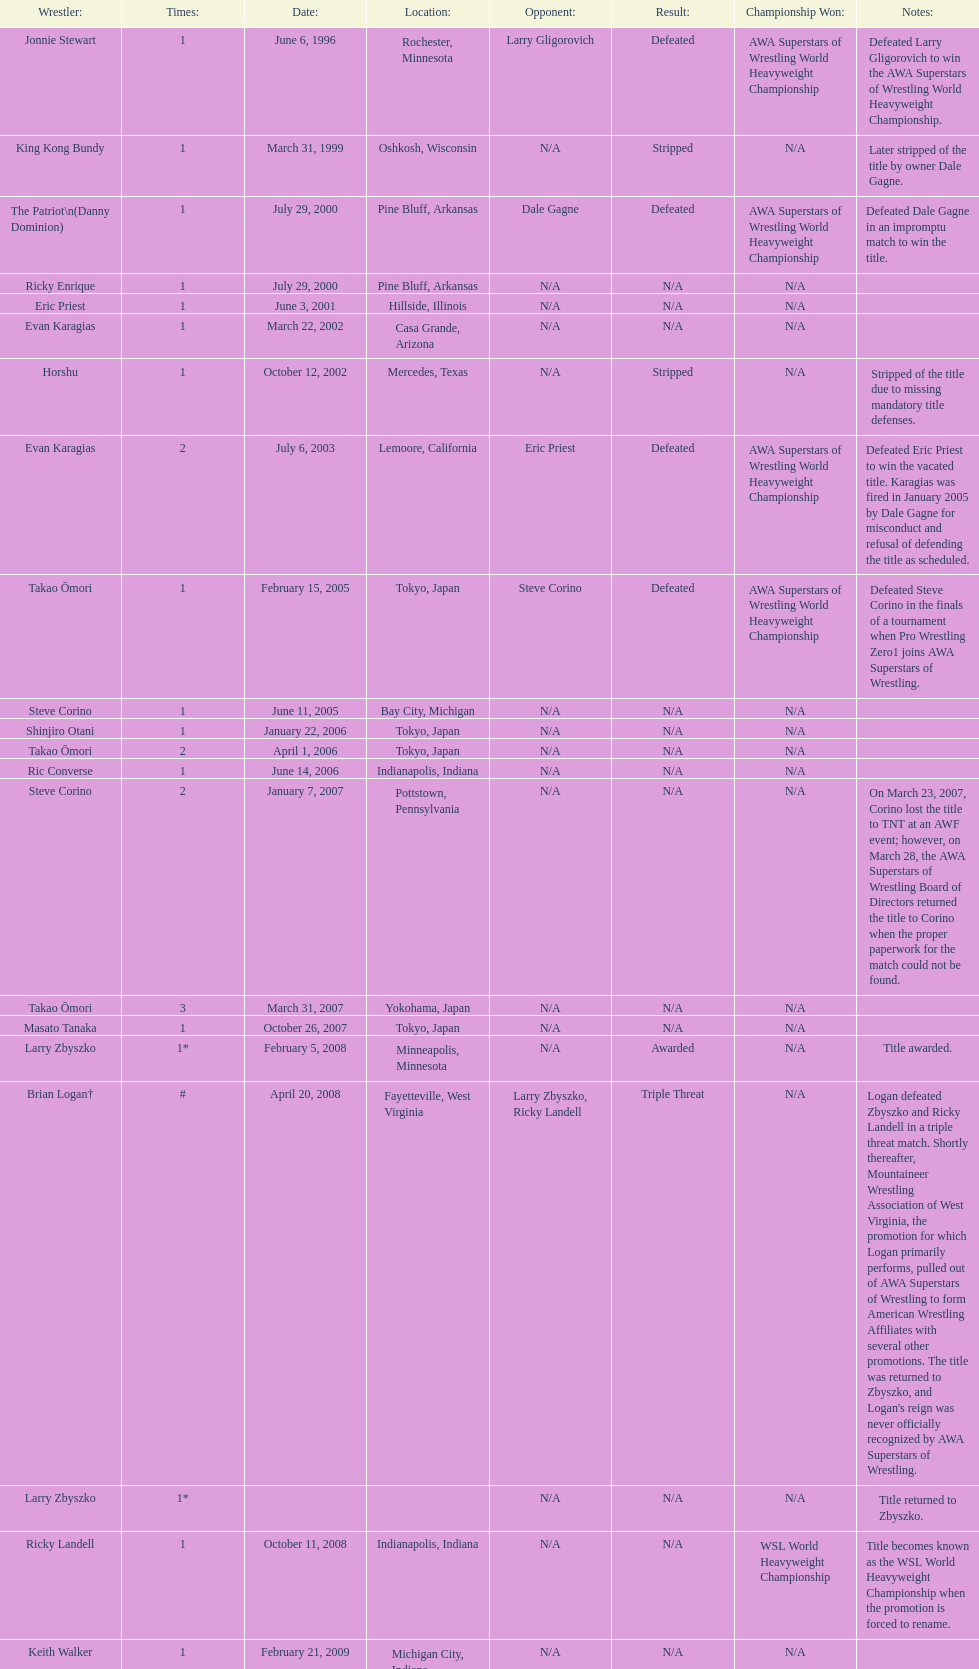The patriot (danny dominion) won the title from what previous holder through an impromptu match? Dale Gagne. 